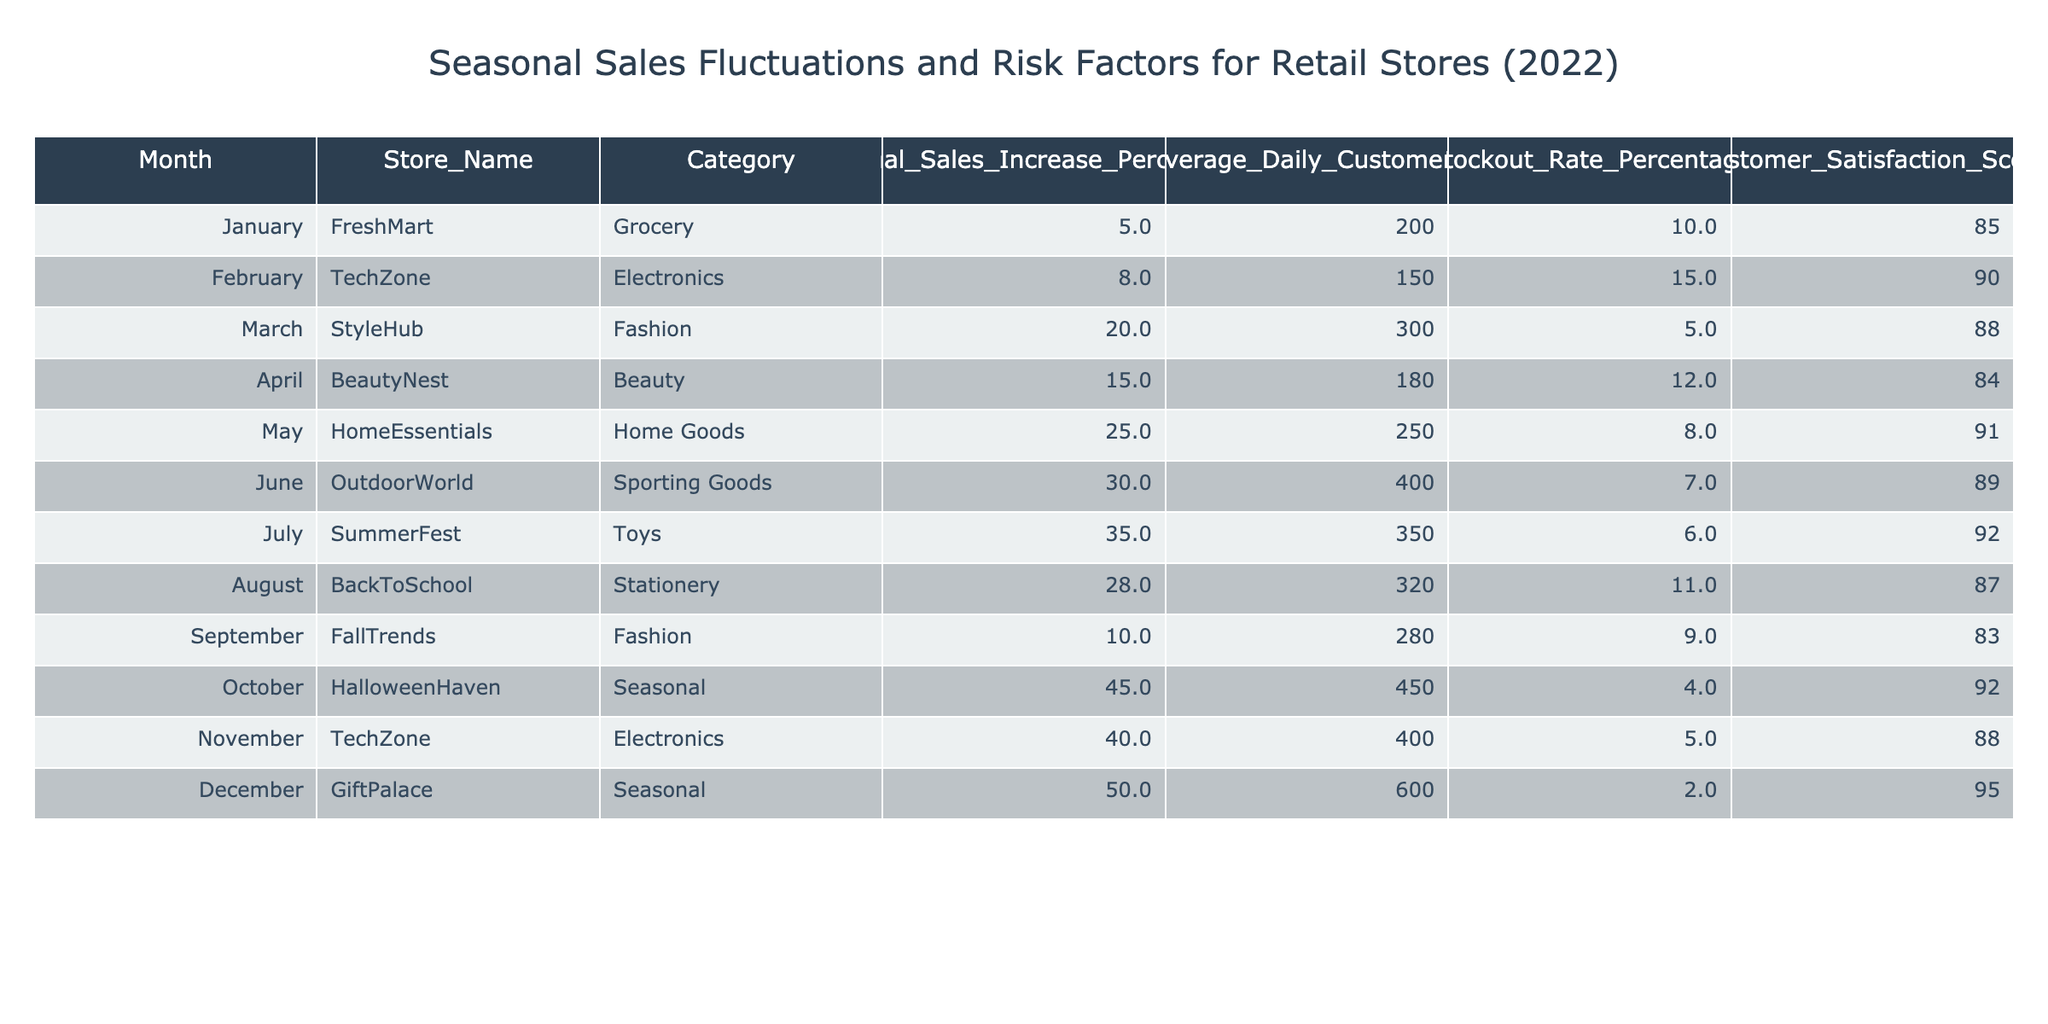What was the customer satisfaction score for HomeEssentials in May? The table displays the customer satisfaction score in the column corresponding to HomeEssentials under the month of May, which is 91.
Answer: 91 What is the stockout rate percentage for HalloweenHaven in October? In October, the table indicates that HalloweenHaven has a stockout rate percentage of 4.
Answer: 4 Which store experienced the highest seasonal sales increase percentage, and what was that percentage? The highest seasonal sales increase percentage is found by comparing the values across the Seasonal Sales Increase Percentage column; it is 50 for GiftPalace in December.
Answer: GiftPalace, 50 What is the average stockout rate percentage for all stores in the table? To find the average, sum the stockout rate percentages (10 + 15 + 5 + 12 + 8 + 7 + 6 + 11 + 9 + 4 + 5 + 2 = 88) and then divide by the number of stores (12); thus, the average is 88/12 = 7.33.
Answer: 7.33 Is it true that TechZone has a higher customer satisfaction score in November than in February? By comparing the customer satisfaction scores for TechZone, November shows a score of 88 while February shows a score of 90; therefore, this statement is false.
Answer: No What is the total percentage increase in seasonal sales from May to July? To find the total increase from May (25) to July (35), subtract May’s percentage from July’s (35 - 25 = 10). Thus, the total increase is 10 percentage points.
Answer: 10 Which category had the lowest average daily customers, and what was the number? By examining the Average Daily Customers column, TechZone presents the lowest number at 150 in February, as all other values are higher.
Answer: TechZone, 150 What is the difference in customer satisfaction scores between December and July? The customer satisfaction score for GiftPalace in December is 95, while for SummerFest in July it is 92. The difference is calculated by subtracting July's score from December's (95 - 92 = 3).
Answer: 3 Which month had the highest average daily customers, and what was that value? The maximum average daily number is located in the Average Daily Customers column, corresponding to December (600).
Answer: December, 600 